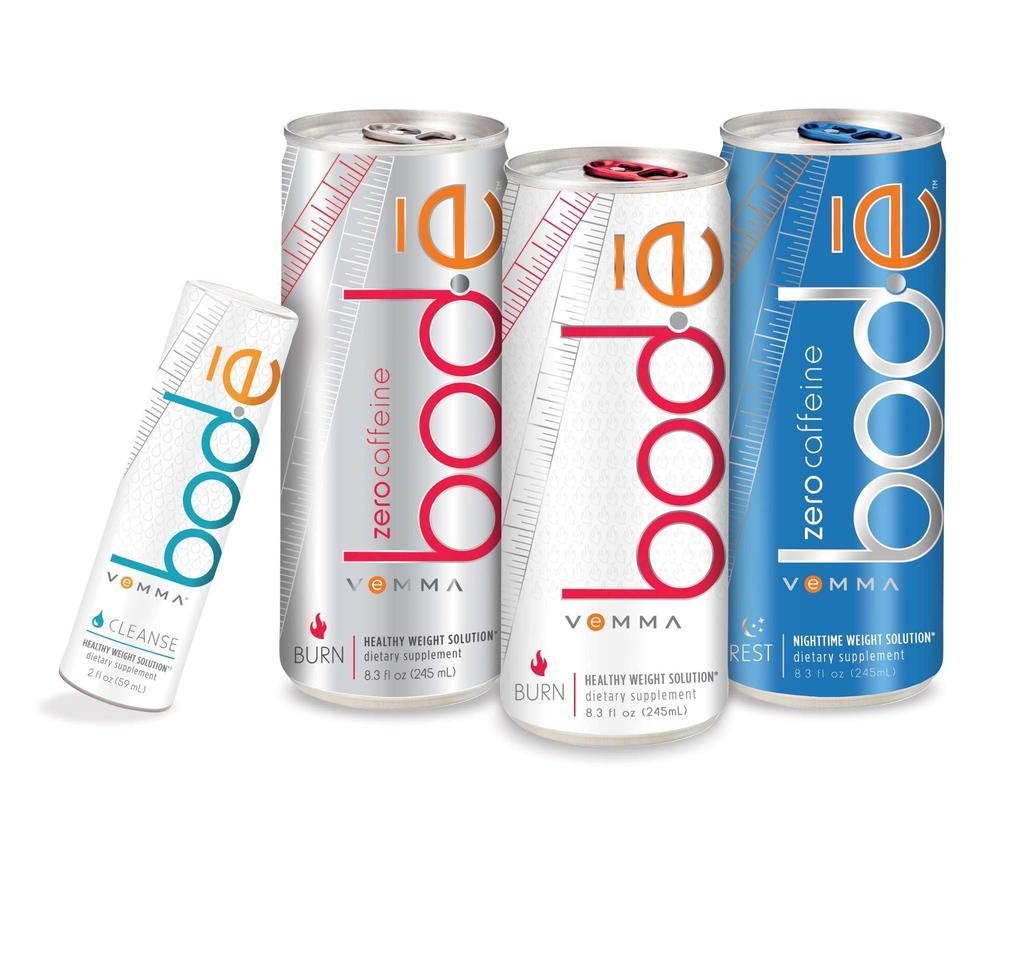<image>
Share a concise interpretation of the image provided. Several cans of bode vemma are on display, containing zero caffeine. 